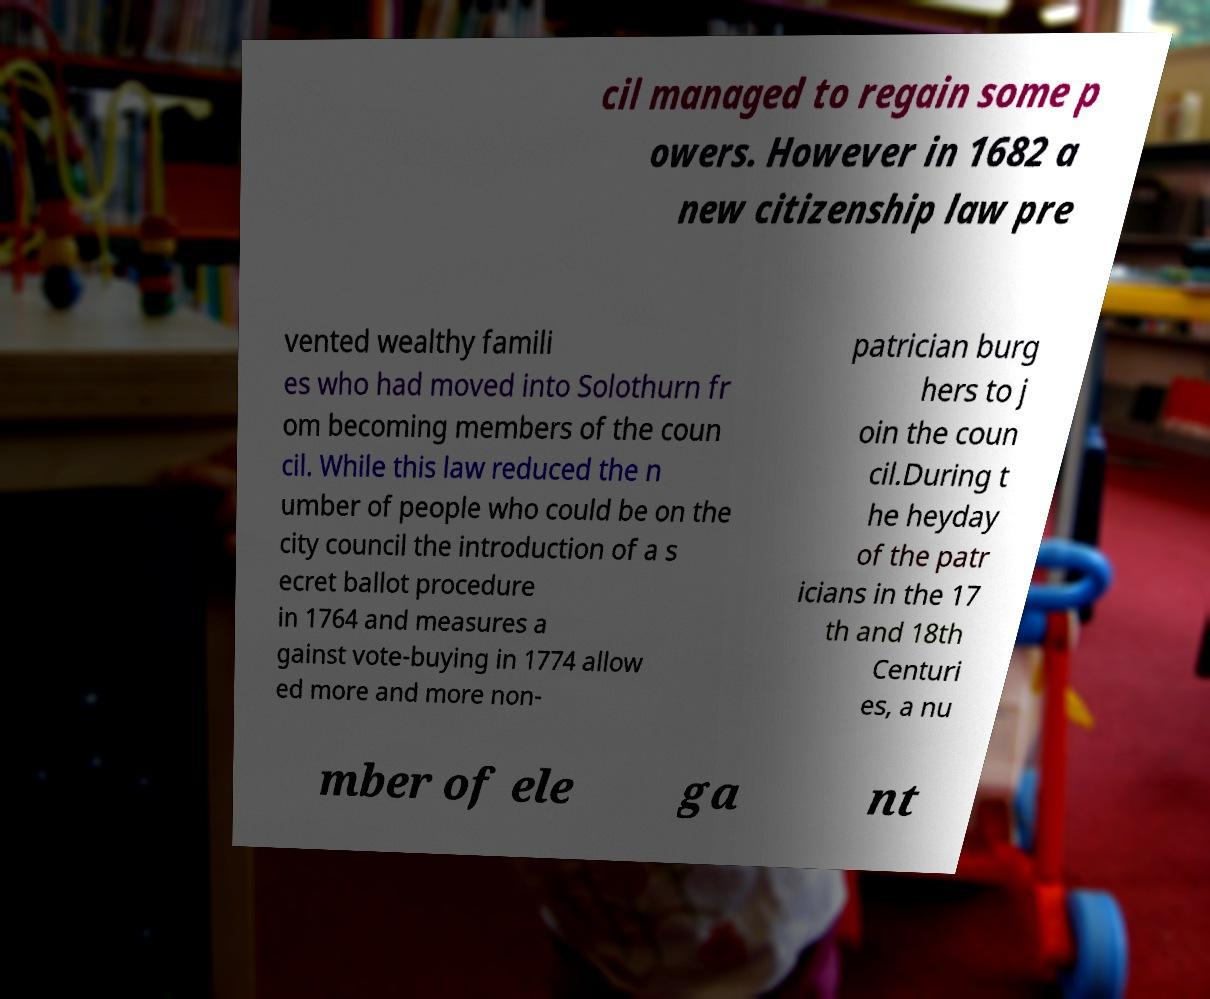What messages or text are displayed in this image? I need them in a readable, typed format. cil managed to regain some p owers. However in 1682 a new citizenship law pre vented wealthy famili es who had moved into Solothurn fr om becoming members of the coun cil. While this law reduced the n umber of people who could be on the city council the introduction of a s ecret ballot procedure in 1764 and measures a gainst vote-buying in 1774 allow ed more and more non- patrician burg hers to j oin the coun cil.During t he heyday of the patr icians in the 17 th and 18th Centuri es, a nu mber of ele ga nt 